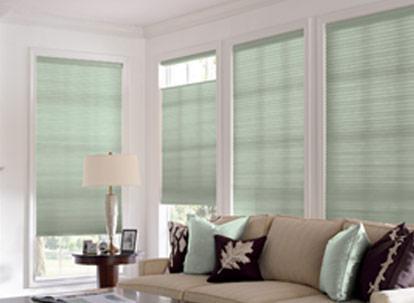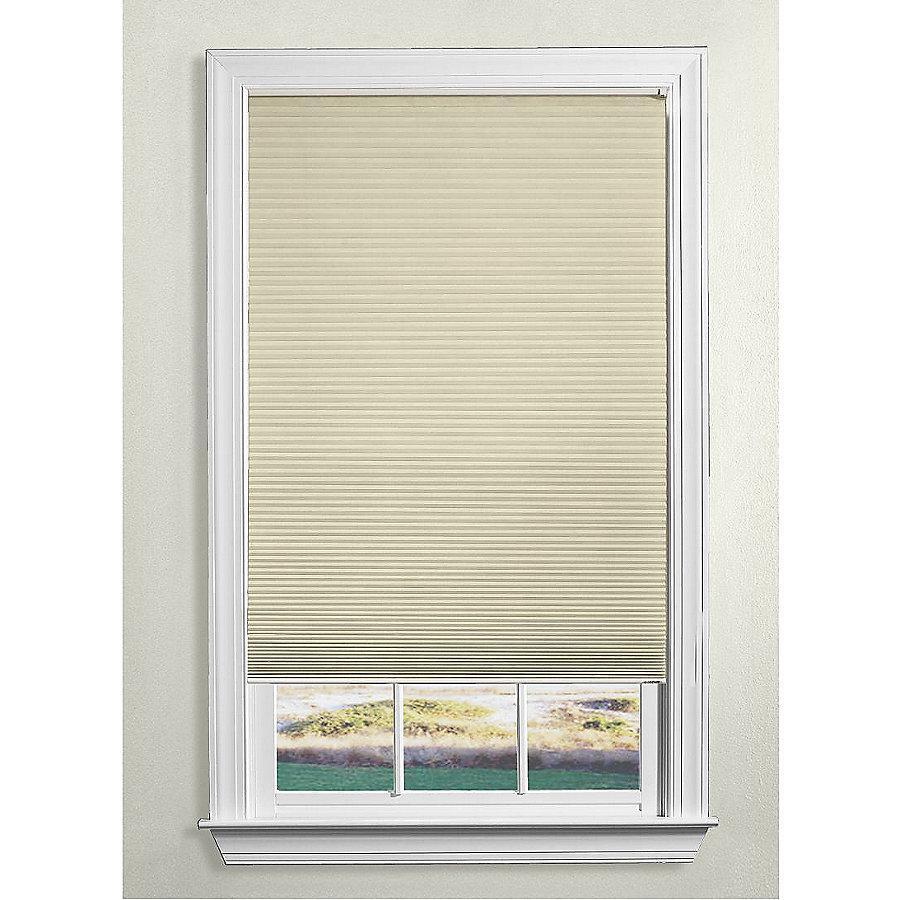The first image is the image on the left, the second image is the image on the right. Evaluate the accuracy of this statement regarding the images: "The left image includes at least two white-framed rectangular windows with colored shades and no drapes, behind beige furniture piled with pillows.". Is it true? Answer yes or no. Yes. 